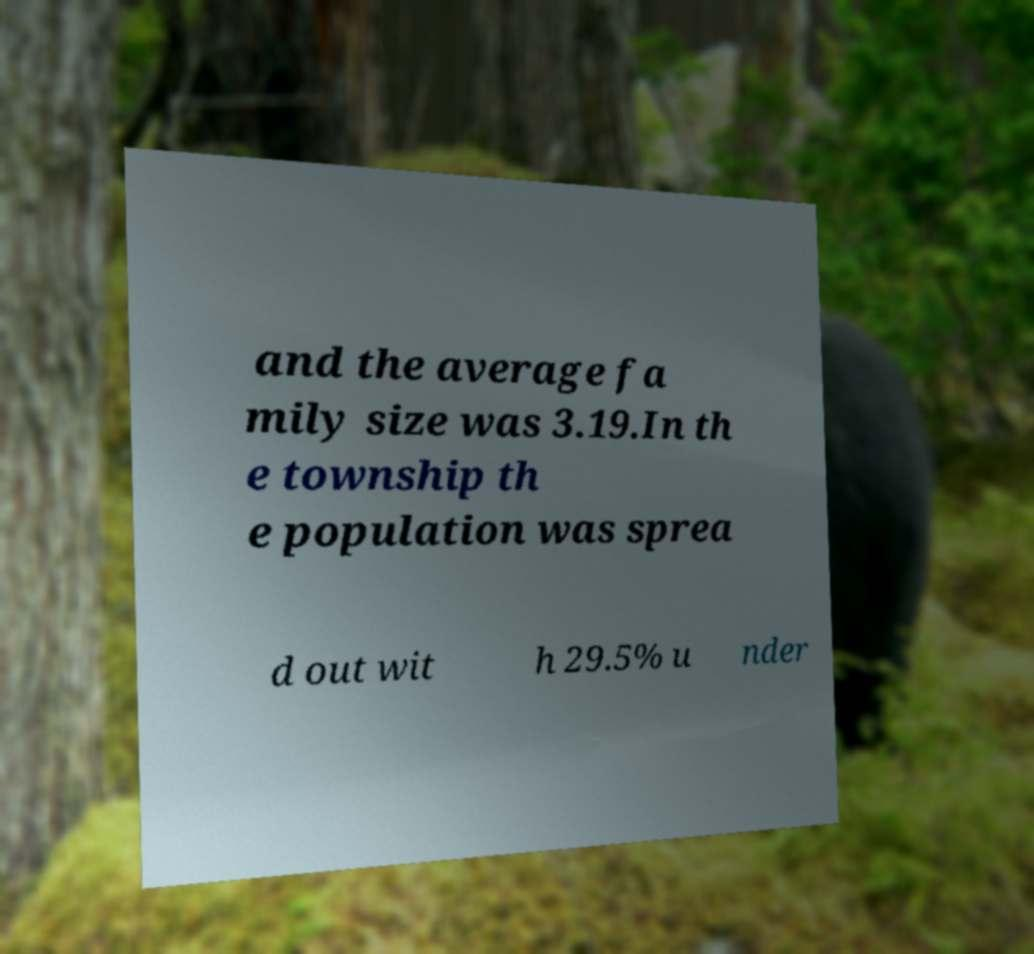Can you accurately transcribe the text from the provided image for me? and the average fa mily size was 3.19.In th e township th e population was sprea d out wit h 29.5% u nder 